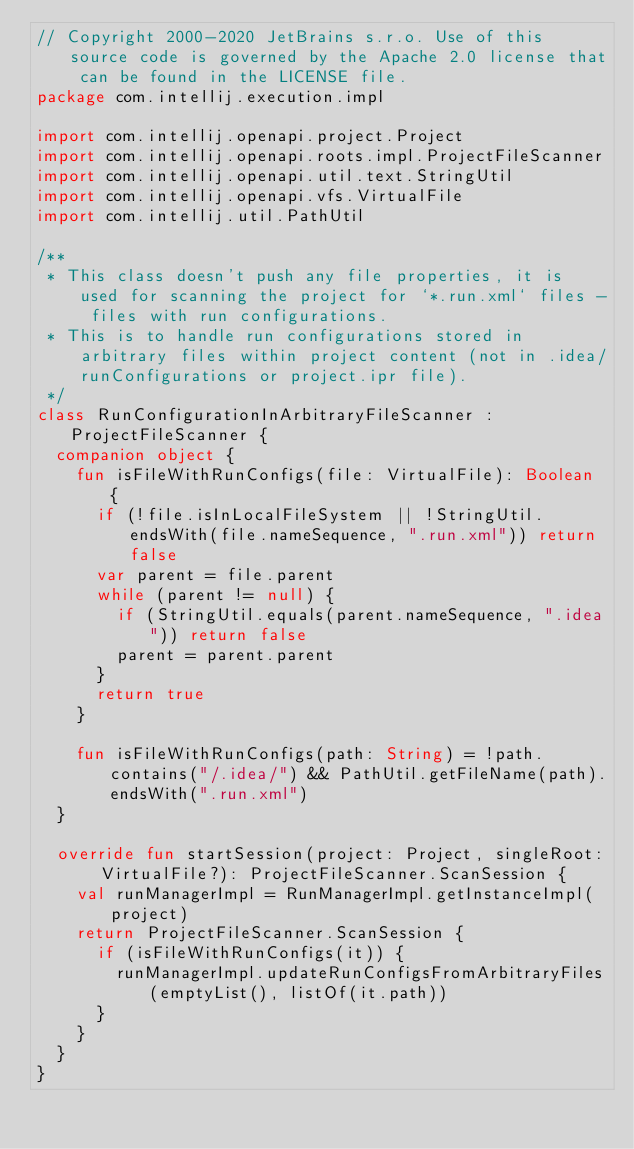<code> <loc_0><loc_0><loc_500><loc_500><_Kotlin_>// Copyright 2000-2020 JetBrains s.r.o. Use of this source code is governed by the Apache 2.0 license that can be found in the LICENSE file.
package com.intellij.execution.impl

import com.intellij.openapi.project.Project
import com.intellij.openapi.roots.impl.ProjectFileScanner
import com.intellij.openapi.util.text.StringUtil
import com.intellij.openapi.vfs.VirtualFile
import com.intellij.util.PathUtil

/**
 * This class doesn't push any file properties, it is used for scanning the project for `*.run.xml` files - files with run configurations.
 * This is to handle run configurations stored in arbitrary files within project content (not in .idea/runConfigurations or project.ipr file).
 */
class RunConfigurationInArbitraryFileScanner : ProjectFileScanner {
  companion object {
    fun isFileWithRunConfigs(file: VirtualFile): Boolean {
      if (!file.isInLocalFileSystem || !StringUtil.endsWith(file.nameSequence, ".run.xml")) return false
      var parent = file.parent
      while (parent != null) {
        if (StringUtil.equals(parent.nameSequence, ".idea")) return false
        parent = parent.parent
      }
      return true
    }

    fun isFileWithRunConfigs(path: String) = !path.contains("/.idea/") && PathUtil.getFileName(path).endsWith(".run.xml")
  }

  override fun startSession(project: Project, singleRoot: VirtualFile?): ProjectFileScanner.ScanSession {
    val runManagerImpl = RunManagerImpl.getInstanceImpl(project)
    return ProjectFileScanner.ScanSession {
      if (isFileWithRunConfigs(it)) {
        runManagerImpl.updateRunConfigsFromArbitraryFiles(emptyList(), listOf(it.path))
      }
    }
  }
}</code> 